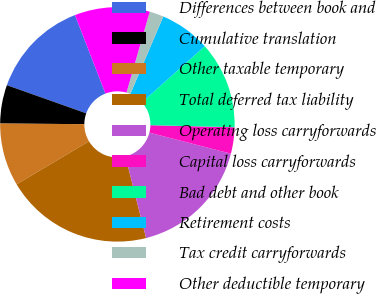Convert chart to OTSL. <chart><loc_0><loc_0><loc_500><loc_500><pie_chart><fcel>Differences between book and<fcel>Cumulative translation<fcel>Other taxable temporary<fcel>Total deferred tax liability<fcel>Operating loss carryforwards<fcel>Capital loss carryforwards<fcel>Bad debt and other book<fcel>Retirement costs<fcel>Tax credit carryforwards<fcel>Other deductible temporary<nl><fcel>13.69%<fcel>5.31%<fcel>8.66%<fcel>20.4%<fcel>17.04%<fcel>3.63%<fcel>12.01%<fcel>6.98%<fcel>1.95%<fcel>10.34%<nl></chart> 